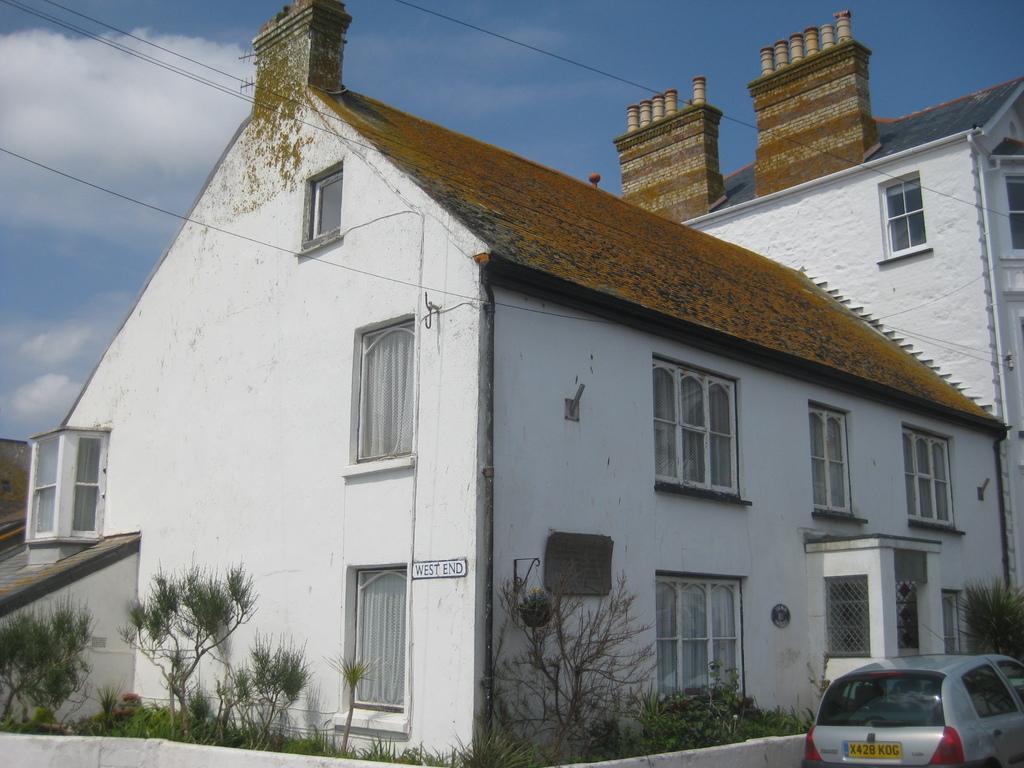How would you summarize this image in a sentence or two? In the center of the image we can see house, windows, plants, board, wall, roof, wires are there. At the bottom right corner a car is there. At the top of the image clouds are present in the sky. 